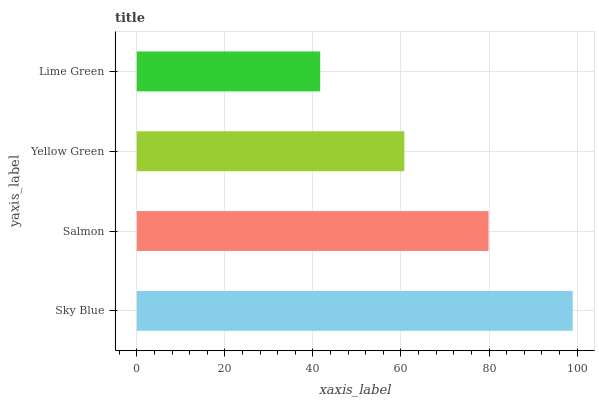Is Lime Green the minimum?
Answer yes or no. Yes. Is Sky Blue the maximum?
Answer yes or no. Yes. Is Salmon the minimum?
Answer yes or no. No. Is Salmon the maximum?
Answer yes or no. No. Is Sky Blue greater than Salmon?
Answer yes or no. Yes. Is Salmon less than Sky Blue?
Answer yes or no. Yes. Is Salmon greater than Sky Blue?
Answer yes or no. No. Is Sky Blue less than Salmon?
Answer yes or no. No. Is Salmon the high median?
Answer yes or no. Yes. Is Yellow Green the low median?
Answer yes or no. Yes. Is Yellow Green the high median?
Answer yes or no. No. Is Sky Blue the low median?
Answer yes or no. No. 